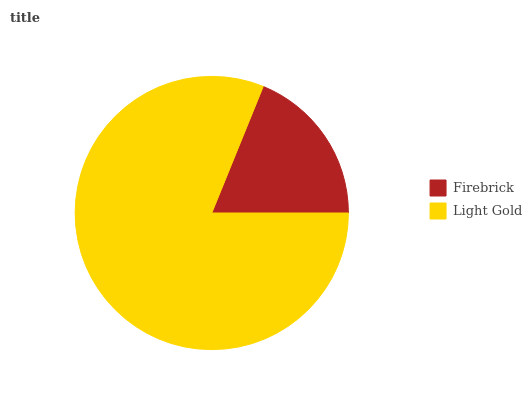Is Firebrick the minimum?
Answer yes or no. Yes. Is Light Gold the maximum?
Answer yes or no. Yes. Is Light Gold the minimum?
Answer yes or no. No. Is Light Gold greater than Firebrick?
Answer yes or no. Yes. Is Firebrick less than Light Gold?
Answer yes or no. Yes. Is Firebrick greater than Light Gold?
Answer yes or no. No. Is Light Gold less than Firebrick?
Answer yes or no. No. Is Light Gold the high median?
Answer yes or no. Yes. Is Firebrick the low median?
Answer yes or no. Yes. Is Firebrick the high median?
Answer yes or no. No. Is Light Gold the low median?
Answer yes or no. No. 